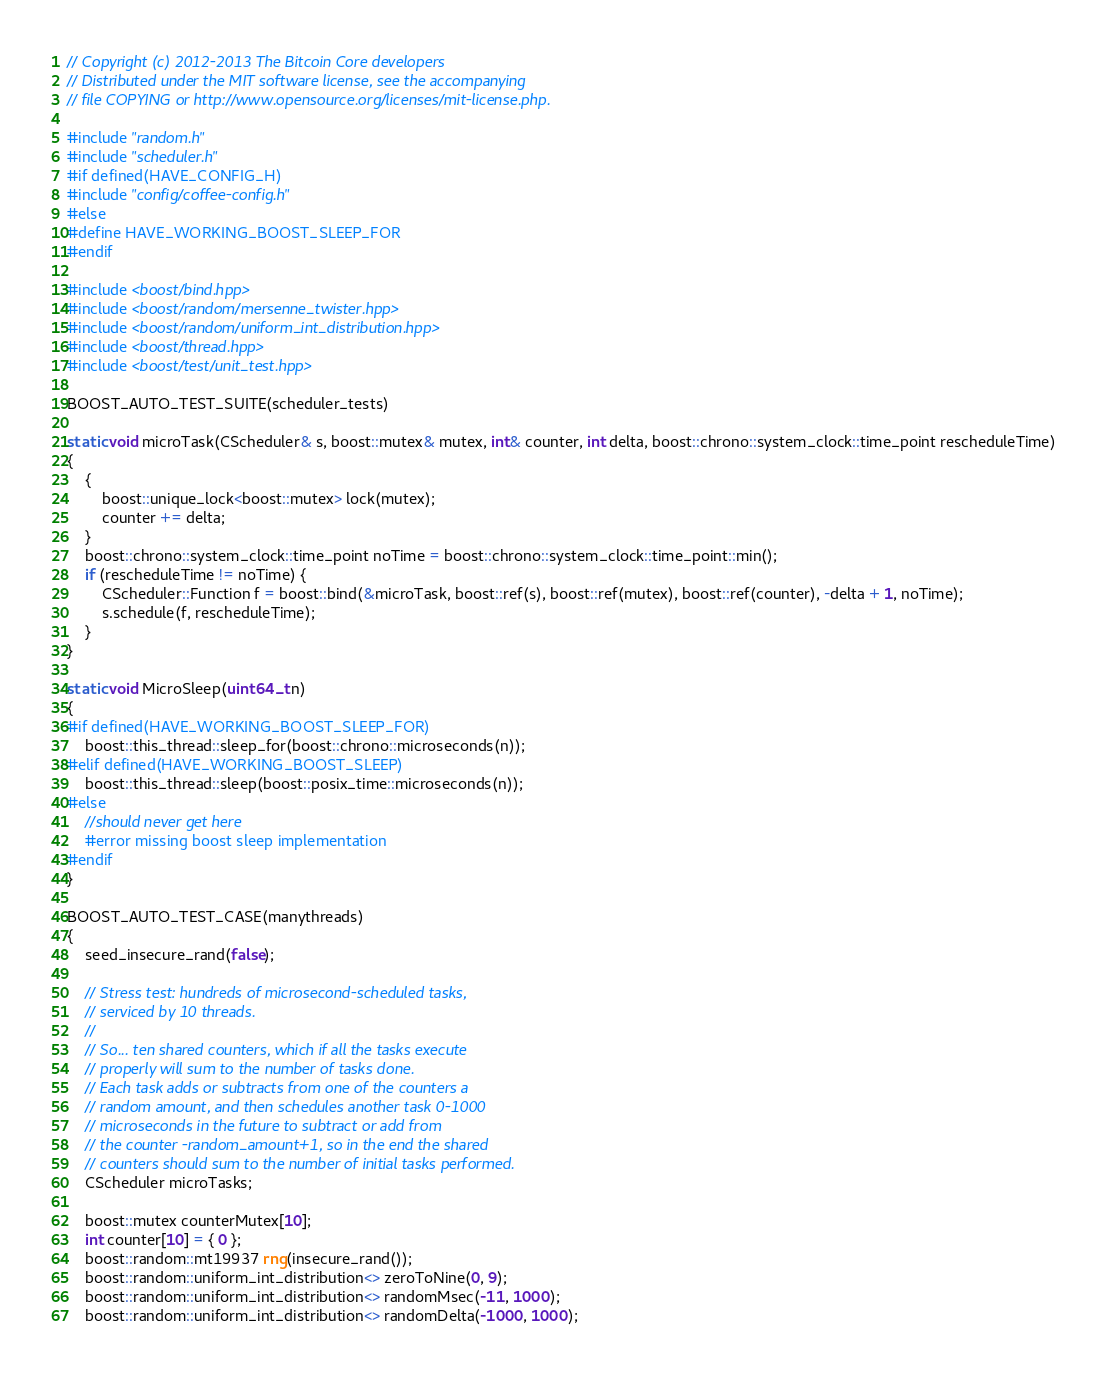<code> <loc_0><loc_0><loc_500><loc_500><_C++_>// Copyright (c) 2012-2013 The Bitcoin Core developers
// Distributed under the MIT software license, see the accompanying
// file COPYING or http://www.opensource.org/licenses/mit-license.php.

#include "random.h"
#include "scheduler.h"
#if defined(HAVE_CONFIG_H)
#include "config/coffee-config.h"
#else
#define HAVE_WORKING_BOOST_SLEEP_FOR
#endif

#include <boost/bind.hpp>
#include <boost/random/mersenne_twister.hpp>
#include <boost/random/uniform_int_distribution.hpp>
#include <boost/thread.hpp>
#include <boost/test/unit_test.hpp>

BOOST_AUTO_TEST_SUITE(scheduler_tests)

static void microTask(CScheduler& s, boost::mutex& mutex, int& counter, int delta, boost::chrono::system_clock::time_point rescheduleTime)
{
    {
        boost::unique_lock<boost::mutex> lock(mutex);
        counter += delta;
    }
    boost::chrono::system_clock::time_point noTime = boost::chrono::system_clock::time_point::min();
    if (rescheduleTime != noTime) {
        CScheduler::Function f = boost::bind(&microTask, boost::ref(s), boost::ref(mutex), boost::ref(counter), -delta + 1, noTime);
        s.schedule(f, rescheduleTime);
    }
}

static void MicroSleep(uint64_t n)
{
#if defined(HAVE_WORKING_BOOST_SLEEP_FOR)
    boost::this_thread::sleep_for(boost::chrono::microseconds(n));
#elif defined(HAVE_WORKING_BOOST_SLEEP)
    boost::this_thread::sleep(boost::posix_time::microseconds(n));
#else
    //should never get here
    #error missing boost sleep implementation
#endif
}

BOOST_AUTO_TEST_CASE(manythreads)
{
    seed_insecure_rand(false);

    // Stress test: hundreds of microsecond-scheduled tasks,
    // serviced by 10 threads.
    //
    // So... ten shared counters, which if all the tasks execute
    // properly will sum to the number of tasks done.
    // Each task adds or subtracts from one of the counters a
    // random amount, and then schedules another task 0-1000
    // microseconds in the future to subtract or add from
    // the counter -random_amount+1, so in the end the shared
    // counters should sum to the number of initial tasks performed.
    CScheduler microTasks;

    boost::mutex counterMutex[10];
    int counter[10] = { 0 };
    boost::random::mt19937 rng(insecure_rand());
    boost::random::uniform_int_distribution<> zeroToNine(0, 9);
    boost::random::uniform_int_distribution<> randomMsec(-11, 1000);
    boost::random::uniform_int_distribution<> randomDelta(-1000, 1000);
</code> 